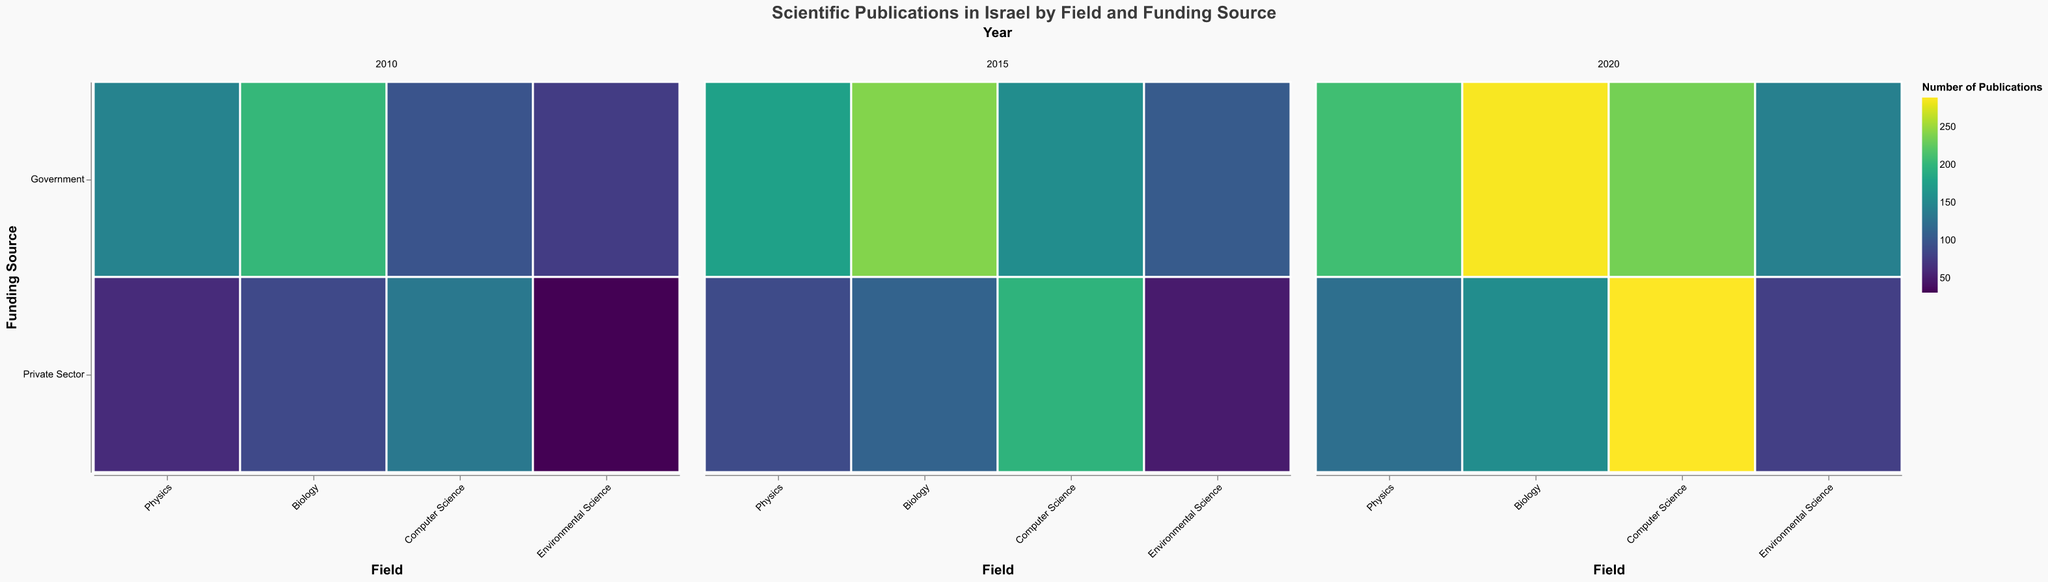What field had the highest number of publications funded by the private sector in 2020? Looking at the plot, locate the year 2020, then find the field with the highest number of private sector publications. The largest rectangle is for Computer Science.
Answer: Computer Science Which funding source saw a greater increase in publications for Physics between 2010 and 2020? Find the publications for Physics in 2010 and 2020 for each funding source. Government increased from 145 to 210 (65) and Private Sector from 62 to 124 (62). The largest increase is with the Government.
Answer: Government How did the number of Biology publications funded by the government change from 2010 to 2020? Locate the values for Biology funded by the government in both years. It increased from 203 in 2010 to 287 in 2020, an increase of 84 publications.
Answer: Increased by 84 Which field experienced the smallest growth in government-funded publications between 2010 and 2020? Calculate the publication differences: Physics (65), Biology (84), Computer Science (137), Environmental Science (66). Physics had the smallest growth (65).
Answer: Physics Comparing 2015 to 2020, which field had the largest percentage increase in private sector publications? Calculate the percentage increase for each field from 2015 to 2020: Physics (39.33%), Biology (39.29%), Computer Science (45.96%), Environmental Science (59.18%). Environmental Science had the largest percentage increase.
Answer: Environmental Science What overall trend can you observe in private sector funding across all fields from 2010 to 2020? Observe the increase in the size of the rectangles for private sector funding across all years. There is a clear upward trend in private sector funding over the decade.
Answer: Increasing trend What proportion of publications in Computer Science was funded by the private sector in 2015? Identify Computer Science publications in 2015. Private sector has 198 and government has 156. Proportion is 198 / (198 + 156) ≈ 0.559 or 55.9%.
Answer: 55.9% In which field did government funding see its most significant increase in 2020 compared to 2015? Compare the increase between 2015 and 2020 for all fields. Computer Science saw the most significant increase from 156 to 235 (79).
Answer: Computer Science Which field had more total publications (both funding sources combined) in 2020, Biology or Physics? Sum the 2020 publications for both sources in each field: Biology (287 + 156 = 443), Physics (210 + 124 = 334). Biology had more.
Answer: Biology Between 2010 and 2020, how did the trend in publications for Environmental Science funded by the private sector change? Note the environmental science publications in 2010 (31), 2015 (49), and 2020 (78). It shows a continuous increase over the years.
Answer: Increased continuously 